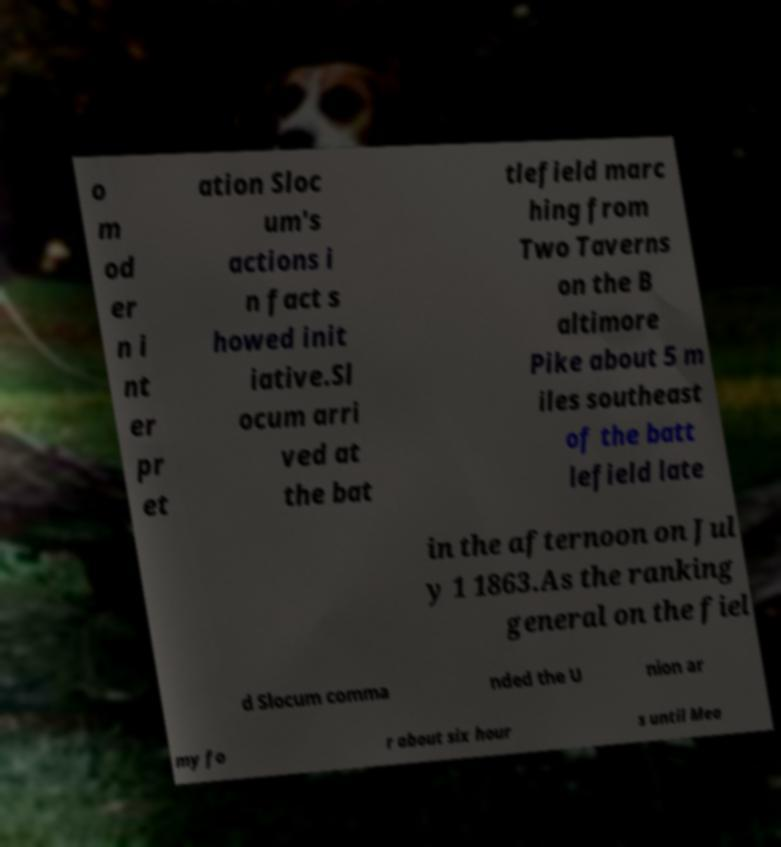Could you extract and type out the text from this image? o m od er n i nt er pr et ation Sloc um's actions i n fact s howed init iative.Sl ocum arri ved at the bat tlefield marc hing from Two Taverns on the B altimore Pike about 5 m iles southeast of the batt lefield late in the afternoon on Jul y 1 1863.As the ranking general on the fiel d Slocum comma nded the U nion ar my fo r about six hour s until Mea 